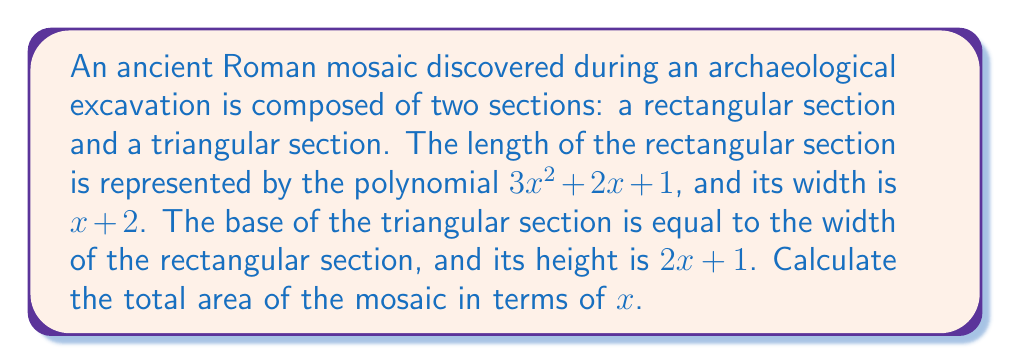Could you help me with this problem? To calculate the total area of the mosaic, we need to find the sum of the areas of the rectangular and triangular sections.

1. Area of the rectangular section:
   $A_r = length \times width$
   $A_r = (3x^2 + 2x + 1)(x + 2)$
   
   Expanding this expression:
   $A_r = 3x^3 + 6x^2 + 2x^2 + 4x + x + 2$
   $A_r = 3x^3 + 8x^2 + 5x + 2$

2. Area of the triangular section:
   $A_t = \frac{1}{2} \times base \times height$
   $A_t = \frac{1}{2}(x + 2)(2x + 1)$
   
   Expanding this expression:
   $A_t = \frac{1}{2}(2x^2 + x + 4x + 2)$
   $A_t = \frac{1}{2}(2x^2 + 5x + 2)$
   $A_t = x^2 + \frac{5}{2}x + 1$

3. Total area of the mosaic:
   $A_{total} = A_r + A_t$
   $A_{total} = (3x^3 + 8x^2 + 5x + 2) + (x^2 + \frac{5}{2}x + 1)$
   
   Combining like terms:
   $A_{total} = 3x^3 + 9x^2 + \frac{15}{2}x + 3$

Therefore, the total area of the ancient mosaic in terms of $x$ is $3x^3 + 9x^2 + \frac{15}{2}x + 3$ square units.
Answer: $3x^3 + 9x^2 + \frac{15}{2}x + 3$ square units 